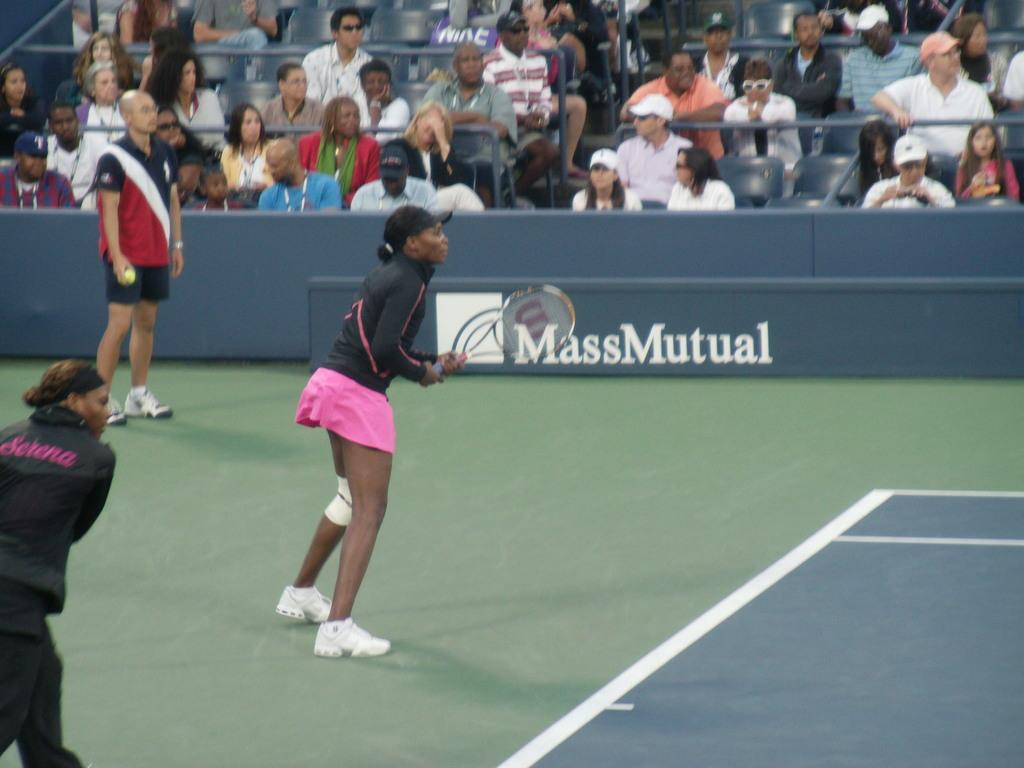Who is the main subject in the image? There is a woman in the image. What is the woman doing in the image? The woman is standing on the floor and holding a racket in her hands. Can you describe the other people in the image? There is a group of people in the image, and they are sitting on chairs. What type of caption is written on the racket in the image? There is no caption written on the racket in the image; it is just a racket being held by the woman. 